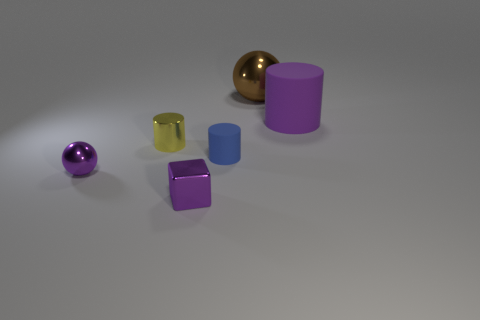Subtract all tiny yellow cylinders. How many cylinders are left? 2 Add 3 small metallic cylinders. How many objects exist? 9 Subtract all spheres. How many objects are left? 4 Subtract 1 blocks. How many blocks are left? 0 Subtract all blue cylinders. How many cylinders are left? 2 Add 5 tiny yellow cylinders. How many tiny yellow cylinders are left? 6 Add 3 blue metallic cubes. How many blue metallic cubes exist? 3 Subtract 0 red cylinders. How many objects are left? 6 Subtract all brown cylinders. Subtract all yellow blocks. How many cylinders are left? 3 Subtract all small cyan spheres. Subtract all big brown metal things. How many objects are left? 5 